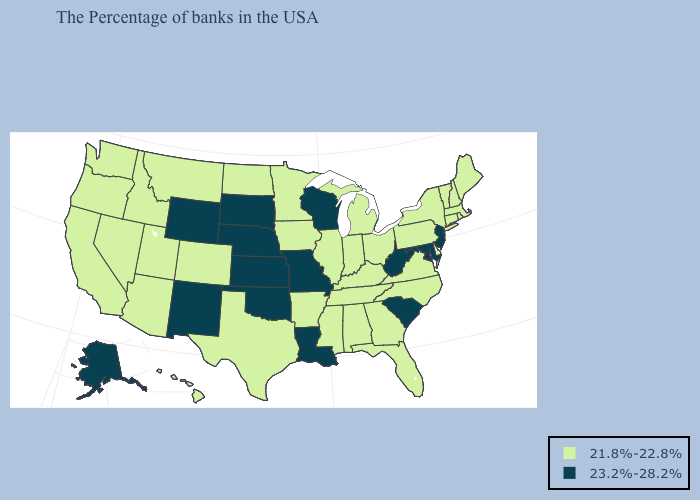Does Oklahoma have the highest value in the South?
Quick response, please. Yes. What is the value of Alaska?
Keep it brief. 23.2%-28.2%. Name the states that have a value in the range 23.2%-28.2%?
Keep it brief. New Jersey, Maryland, South Carolina, West Virginia, Wisconsin, Louisiana, Missouri, Kansas, Nebraska, Oklahoma, South Dakota, Wyoming, New Mexico, Alaska. Does Colorado have a higher value than Missouri?
Keep it brief. No. Among the states that border Iowa , does Wisconsin have the highest value?
Short answer required. Yes. Name the states that have a value in the range 23.2%-28.2%?
Be succinct. New Jersey, Maryland, South Carolina, West Virginia, Wisconsin, Louisiana, Missouri, Kansas, Nebraska, Oklahoma, South Dakota, Wyoming, New Mexico, Alaska. Name the states that have a value in the range 21.8%-22.8%?
Write a very short answer. Maine, Massachusetts, Rhode Island, New Hampshire, Vermont, Connecticut, New York, Delaware, Pennsylvania, Virginia, North Carolina, Ohio, Florida, Georgia, Michigan, Kentucky, Indiana, Alabama, Tennessee, Illinois, Mississippi, Arkansas, Minnesota, Iowa, Texas, North Dakota, Colorado, Utah, Montana, Arizona, Idaho, Nevada, California, Washington, Oregon, Hawaii. Which states have the highest value in the USA?
Be succinct. New Jersey, Maryland, South Carolina, West Virginia, Wisconsin, Louisiana, Missouri, Kansas, Nebraska, Oklahoma, South Dakota, Wyoming, New Mexico, Alaska. Name the states that have a value in the range 21.8%-22.8%?
Answer briefly. Maine, Massachusetts, Rhode Island, New Hampshire, Vermont, Connecticut, New York, Delaware, Pennsylvania, Virginia, North Carolina, Ohio, Florida, Georgia, Michigan, Kentucky, Indiana, Alabama, Tennessee, Illinois, Mississippi, Arkansas, Minnesota, Iowa, Texas, North Dakota, Colorado, Utah, Montana, Arizona, Idaho, Nevada, California, Washington, Oregon, Hawaii. Which states have the lowest value in the MidWest?
Be succinct. Ohio, Michigan, Indiana, Illinois, Minnesota, Iowa, North Dakota. Name the states that have a value in the range 21.8%-22.8%?
Answer briefly. Maine, Massachusetts, Rhode Island, New Hampshire, Vermont, Connecticut, New York, Delaware, Pennsylvania, Virginia, North Carolina, Ohio, Florida, Georgia, Michigan, Kentucky, Indiana, Alabama, Tennessee, Illinois, Mississippi, Arkansas, Minnesota, Iowa, Texas, North Dakota, Colorado, Utah, Montana, Arizona, Idaho, Nevada, California, Washington, Oregon, Hawaii. What is the highest value in the USA?
Quick response, please. 23.2%-28.2%. Does Missouri have a lower value than Florida?
Keep it brief. No. Which states have the lowest value in the South?
Quick response, please. Delaware, Virginia, North Carolina, Florida, Georgia, Kentucky, Alabama, Tennessee, Mississippi, Arkansas, Texas. Does New Mexico have the highest value in the USA?
Write a very short answer. Yes. 